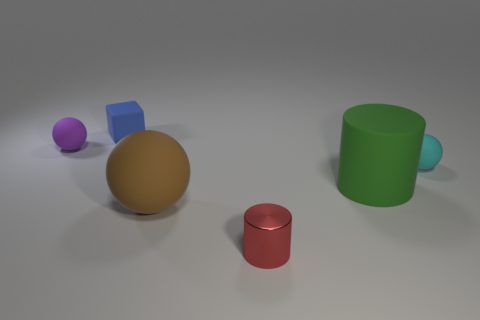What is the tiny red thing made of?
Ensure brevity in your answer.  Metal. Is the number of tiny cyan matte things behind the blue cube greater than the number of big objects?
Ensure brevity in your answer.  No. Is there a tiny matte object?
Make the answer very short. Yes. What number of other things are there of the same shape as the purple matte thing?
Offer a terse response. 2. There is a rubber ball that is to the right of the shiny object; is its color the same as the metal object that is in front of the tiny blue cube?
Provide a short and direct response. No. There is a sphere on the left side of the thing that is behind the rubber ball that is behind the cyan thing; how big is it?
Provide a short and direct response. Small. There is a tiny object that is both right of the small blue block and behind the metallic object; what is its shape?
Provide a succinct answer. Sphere. Is the number of big brown matte spheres that are in front of the big green matte object the same as the number of tiny red cylinders that are behind the brown matte thing?
Give a very brief answer. No. Is there a big yellow block that has the same material as the tiny blue cube?
Your answer should be compact. No. Is the material of the ball on the right side of the large matte sphere the same as the large brown ball?
Your answer should be compact. Yes. 